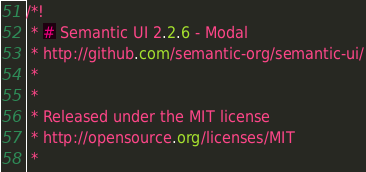<code> <loc_0><loc_0><loc_500><loc_500><_CSS_>/*!
 * # Semantic UI 2.2.6 - Modal
 * http://github.com/semantic-org/semantic-ui/
 *
 *
 * Released under the MIT license
 * http://opensource.org/licenses/MIT
 *</code> 